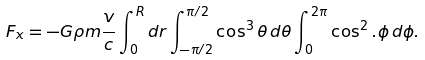Convert formula to latex. <formula><loc_0><loc_0><loc_500><loc_500>F _ { x } = - G \rho m \frac { v } { c } \int _ { 0 } ^ { R } d r \int _ { - \pi / 2 } ^ { \pi / 2 } \cos ^ { 3 } \theta \, d \theta \int _ { 0 } ^ { 2 \pi } \cos ^ { 2 } . \phi \, d \phi .</formula> 